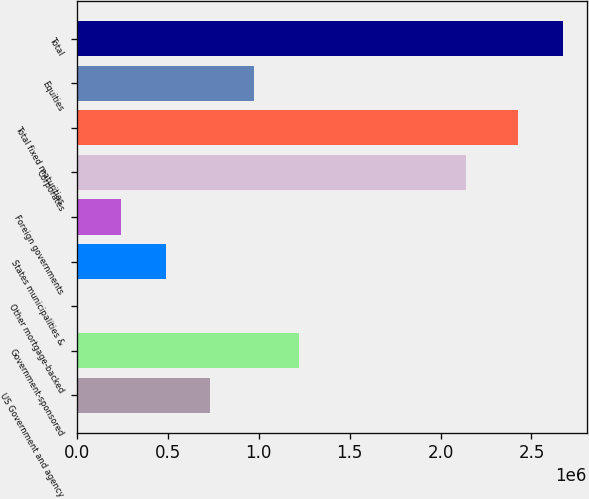Convert chart. <chart><loc_0><loc_0><loc_500><loc_500><bar_chart><fcel>US Government and agency<fcel>Government-sponsored<fcel>Other mortgage-backed<fcel>States municipalities &<fcel>Foreign governments<fcel>Corporates<fcel>Total fixed maturities<fcel>Equities<fcel>Total<nl><fcel>731516<fcel>1.21919e+06<fcel>3<fcel>487678<fcel>243841<fcel>2.14065e+06<fcel>2.42782e+06<fcel>975353<fcel>2.67166e+06<nl></chart> 